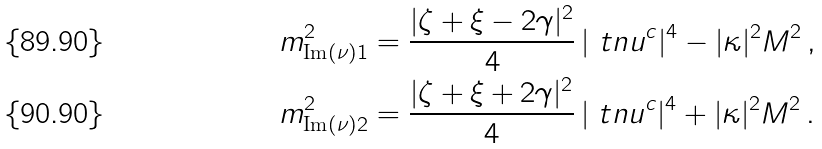Convert formula to latex. <formula><loc_0><loc_0><loc_500><loc_500>m _ { \text {Im} ( \nu ) 1 } ^ { 2 } & = \frac { | \zeta + \xi - 2 \gamma | ^ { 2 } } { 4 } \, | \ t n u ^ { c } | ^ { 4 } - | \kappa | ^ { 2 } M ^ { 2 } \, , \\ m _ { \text {Im} ( \nu ) 2 } ^ { 2 } & = \frac { | \zeta + \xi + 2 \gamma | ^ { 2 } } { 4 } \, | \ t n u ^ { c } | ^ { 4 } + | \kappa | ^ { 2 } M ^ { 2 } \, .</formula> 